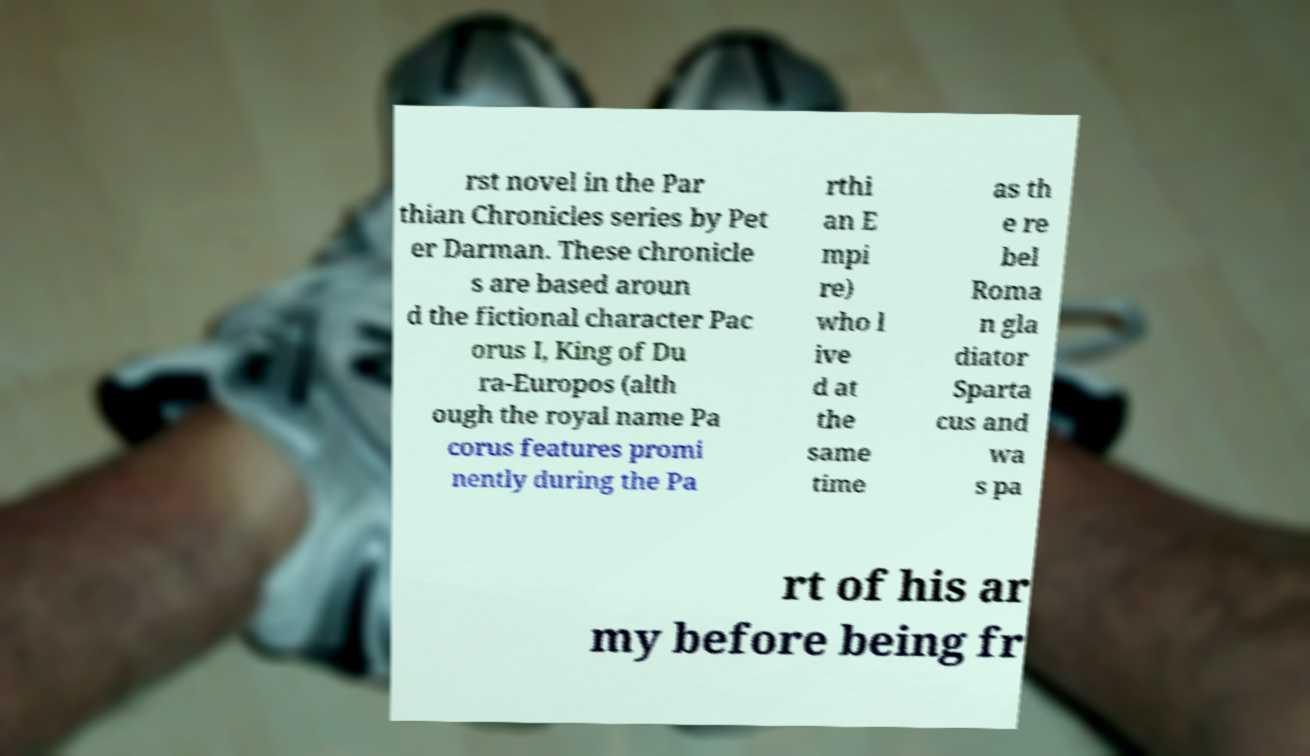Please read and relay the text visible in this image. What does it say? rst novel in the Par thian Chronicles series by Pet er Darman. These chronicle s are based aroun d the fictional character Pac orus I, King of Du ra-Europos (alth ough the royal name Pa corus features promi nently during the Pa rthi an E mpi re) who l ive d at the same time as th e re bel Roma n gla diator Sparta cus and wa s pa rt of his ar my before being fr 